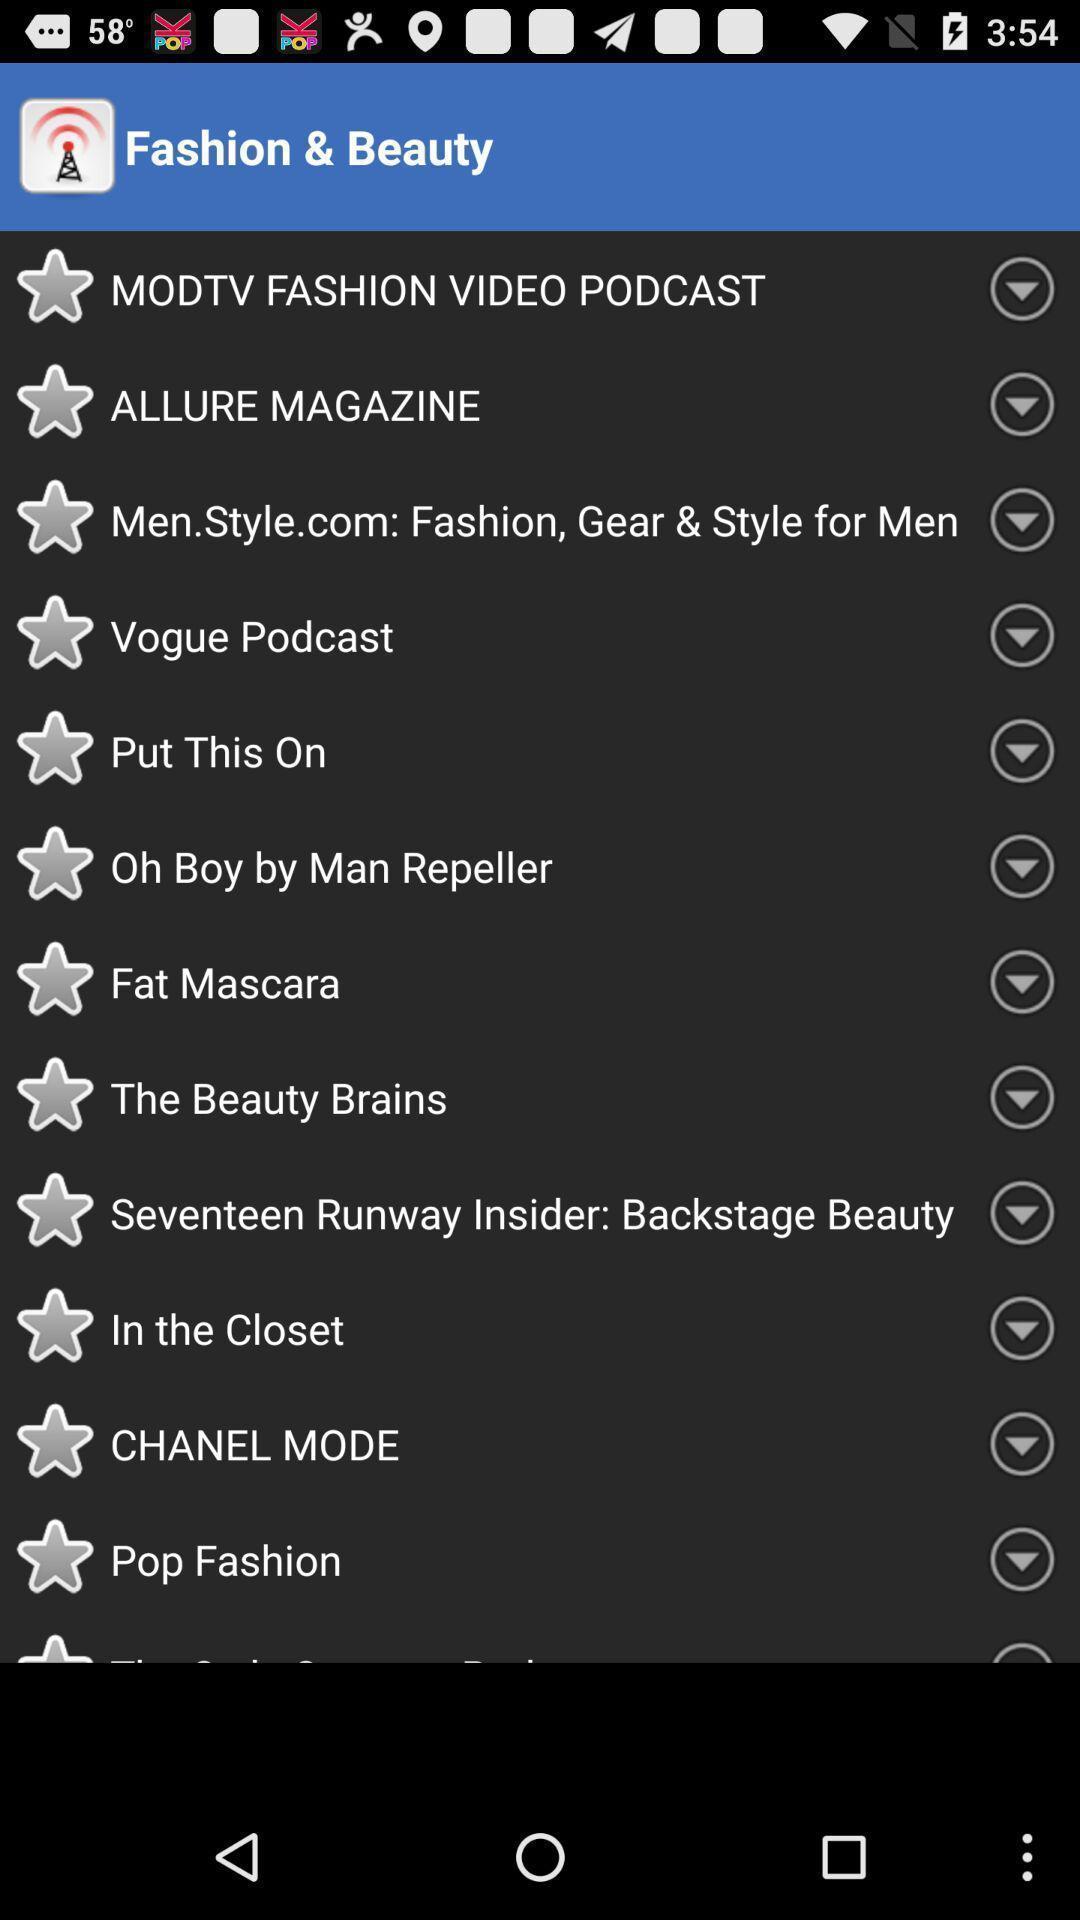Give me a narrative description of this picture. Screen displaying the screen page. 